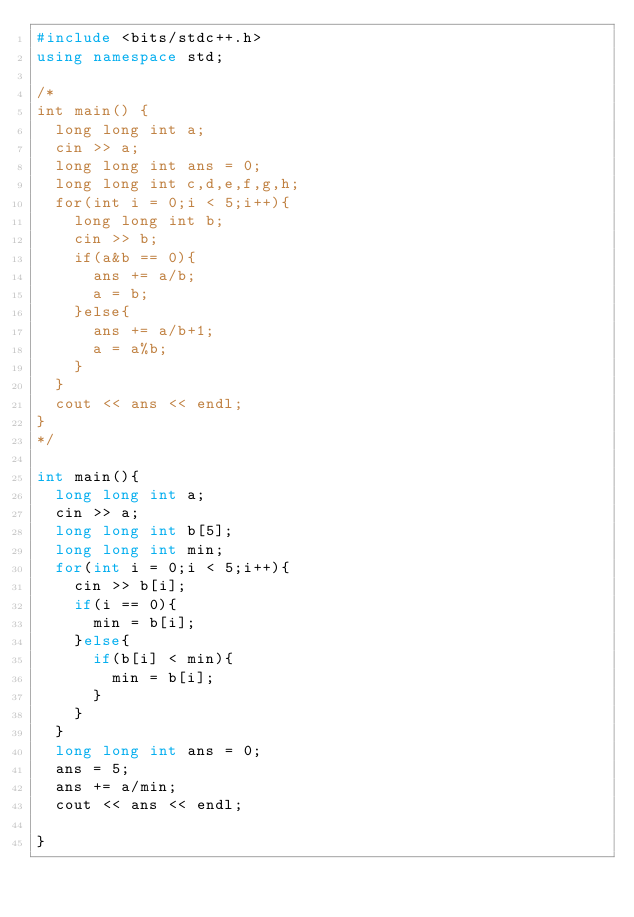Convert code to text. <code><loc_0><loc_0><loc_500><loc_500><_C++_>#include <bits/stdc++.h>
using namespace std;

/*
int main() {
  long long int a;
  cin >> a;
  long long int ans = 0;
  long long int c,d,e,f,g,h;
  for(int i = 0;i < 5;i++){
    long long int b;
    cin >> b;
    if(a&b == 0){
      ans += a/b;
      a = b;
    }else{
      ans += a/b+1;
      a = a%b;
    }
  }
  cout << ans << endl;
}
*/

int main(){
  long long int a;
  cin >> a;
  long long int b[5];
  long long int min;
  for(int i = 0;i < 5;i++){
    cin >> b[i];
    if(i == 0){
      min = b[i];
    }else{
      if(b[i] < min){
        min = b[i];
      }
    }
  }
  long long int ans = 0;
  ans = 5;
  ans += a/min;
  cout << ans << endl;
  
}</code> 